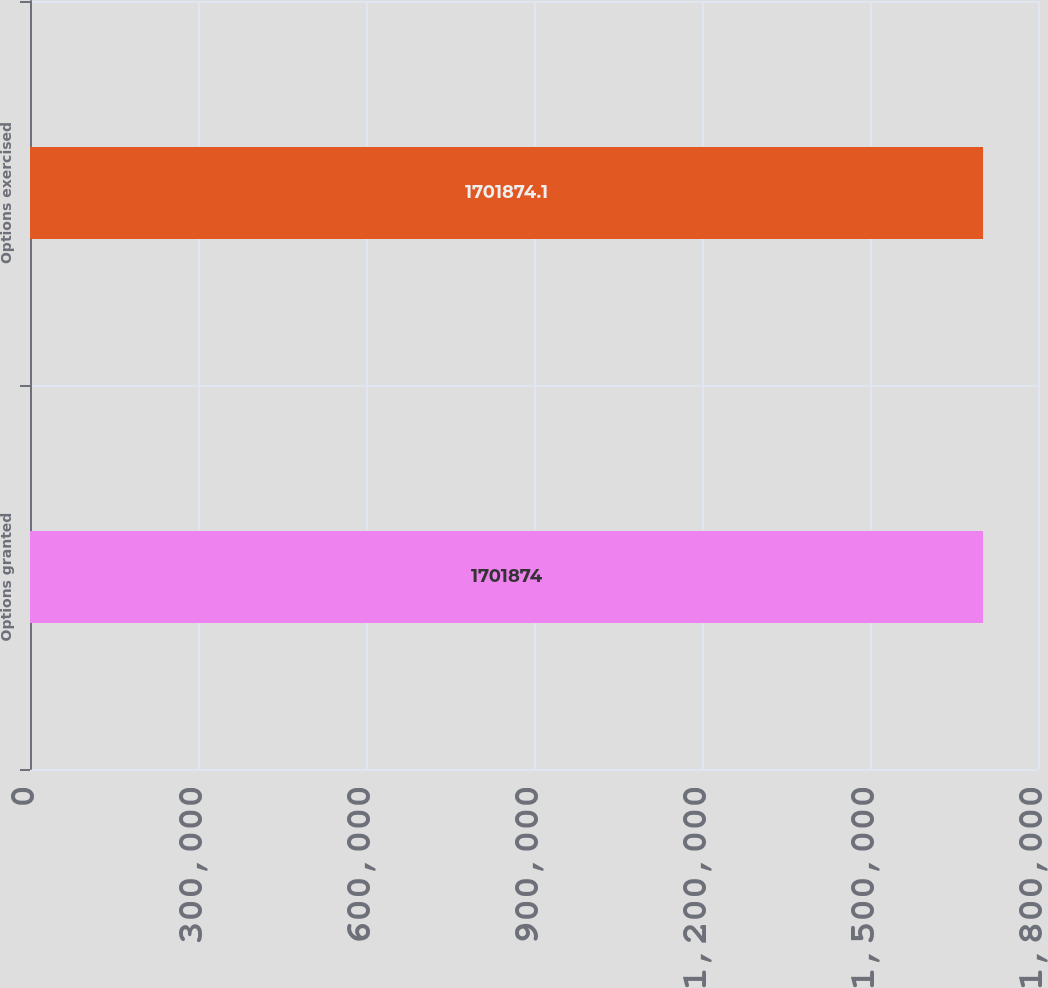Convert chart. <chart><loc_0><loc_0><loc_500><loc_500><bar_chart><fcel>Options granted<fcel>Options exercised<nl><fcel>1.70187e+06<fcel>1.70187e+06<nl></chart> 